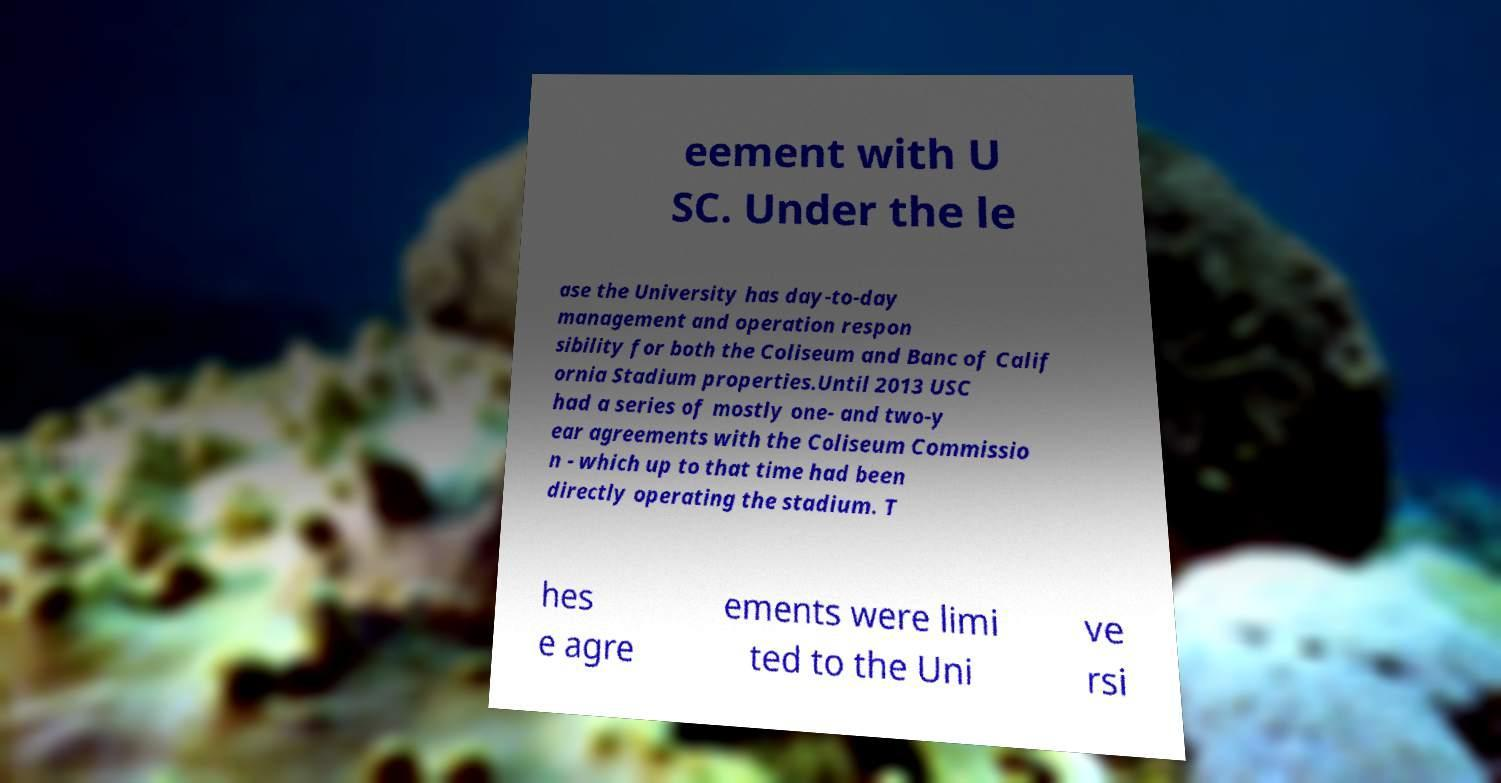For documentation purposes, I need the text within this image transcribed. Could you provide that? eement with U SC. Under the le ase the University has day-to-day management and operation respon sibility for both the Coliseum and Banc of Calif ornia Stadium properties.Until 2013 USC had a series of mostly one- and two-y ear agreements with the Coliseum Commissio n - which up to that time had been directly operating the stadium. T hes e agre ements were limi ted to the Uni ve rsi 